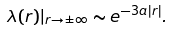<formula> <loc_0><loc_0><loc_500><loc_500>\lambda ( r ) | _ { r \to \pm \infty } \sim e ^ { - 3 a | r | } .</formula> 